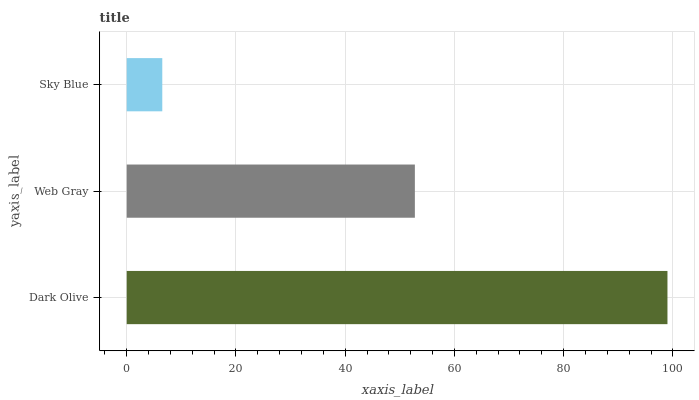Is Sky Blue the minimum?
Answer yes or no. Yes. Is Dark Olive the maximum?
Answer yes or no. Yes. Is Web Gray the minimum?
Answer yes or no. No. Is Web Gray the maximum?
Answer yes or no. No. Is Dark Olive greater than Web Gray?
Answer yes or no. Yes. Is Web Gray less than Dark Olive?
Answer yes or no. Yes. Is Web Gray greater than Dark Olive?
Answer yes or no. No. Is Dark Olive less than Web Gray?
Answer yes or no. No. Is Web Gray the high median?
Answer yes or no. Yes. Is Web Gray the low median?
Answer yes or no. Yes. Is Sky Blue the high median?
Answer yes or no. No. Is Sky Blue the low median?
Answer yes or no. No. 